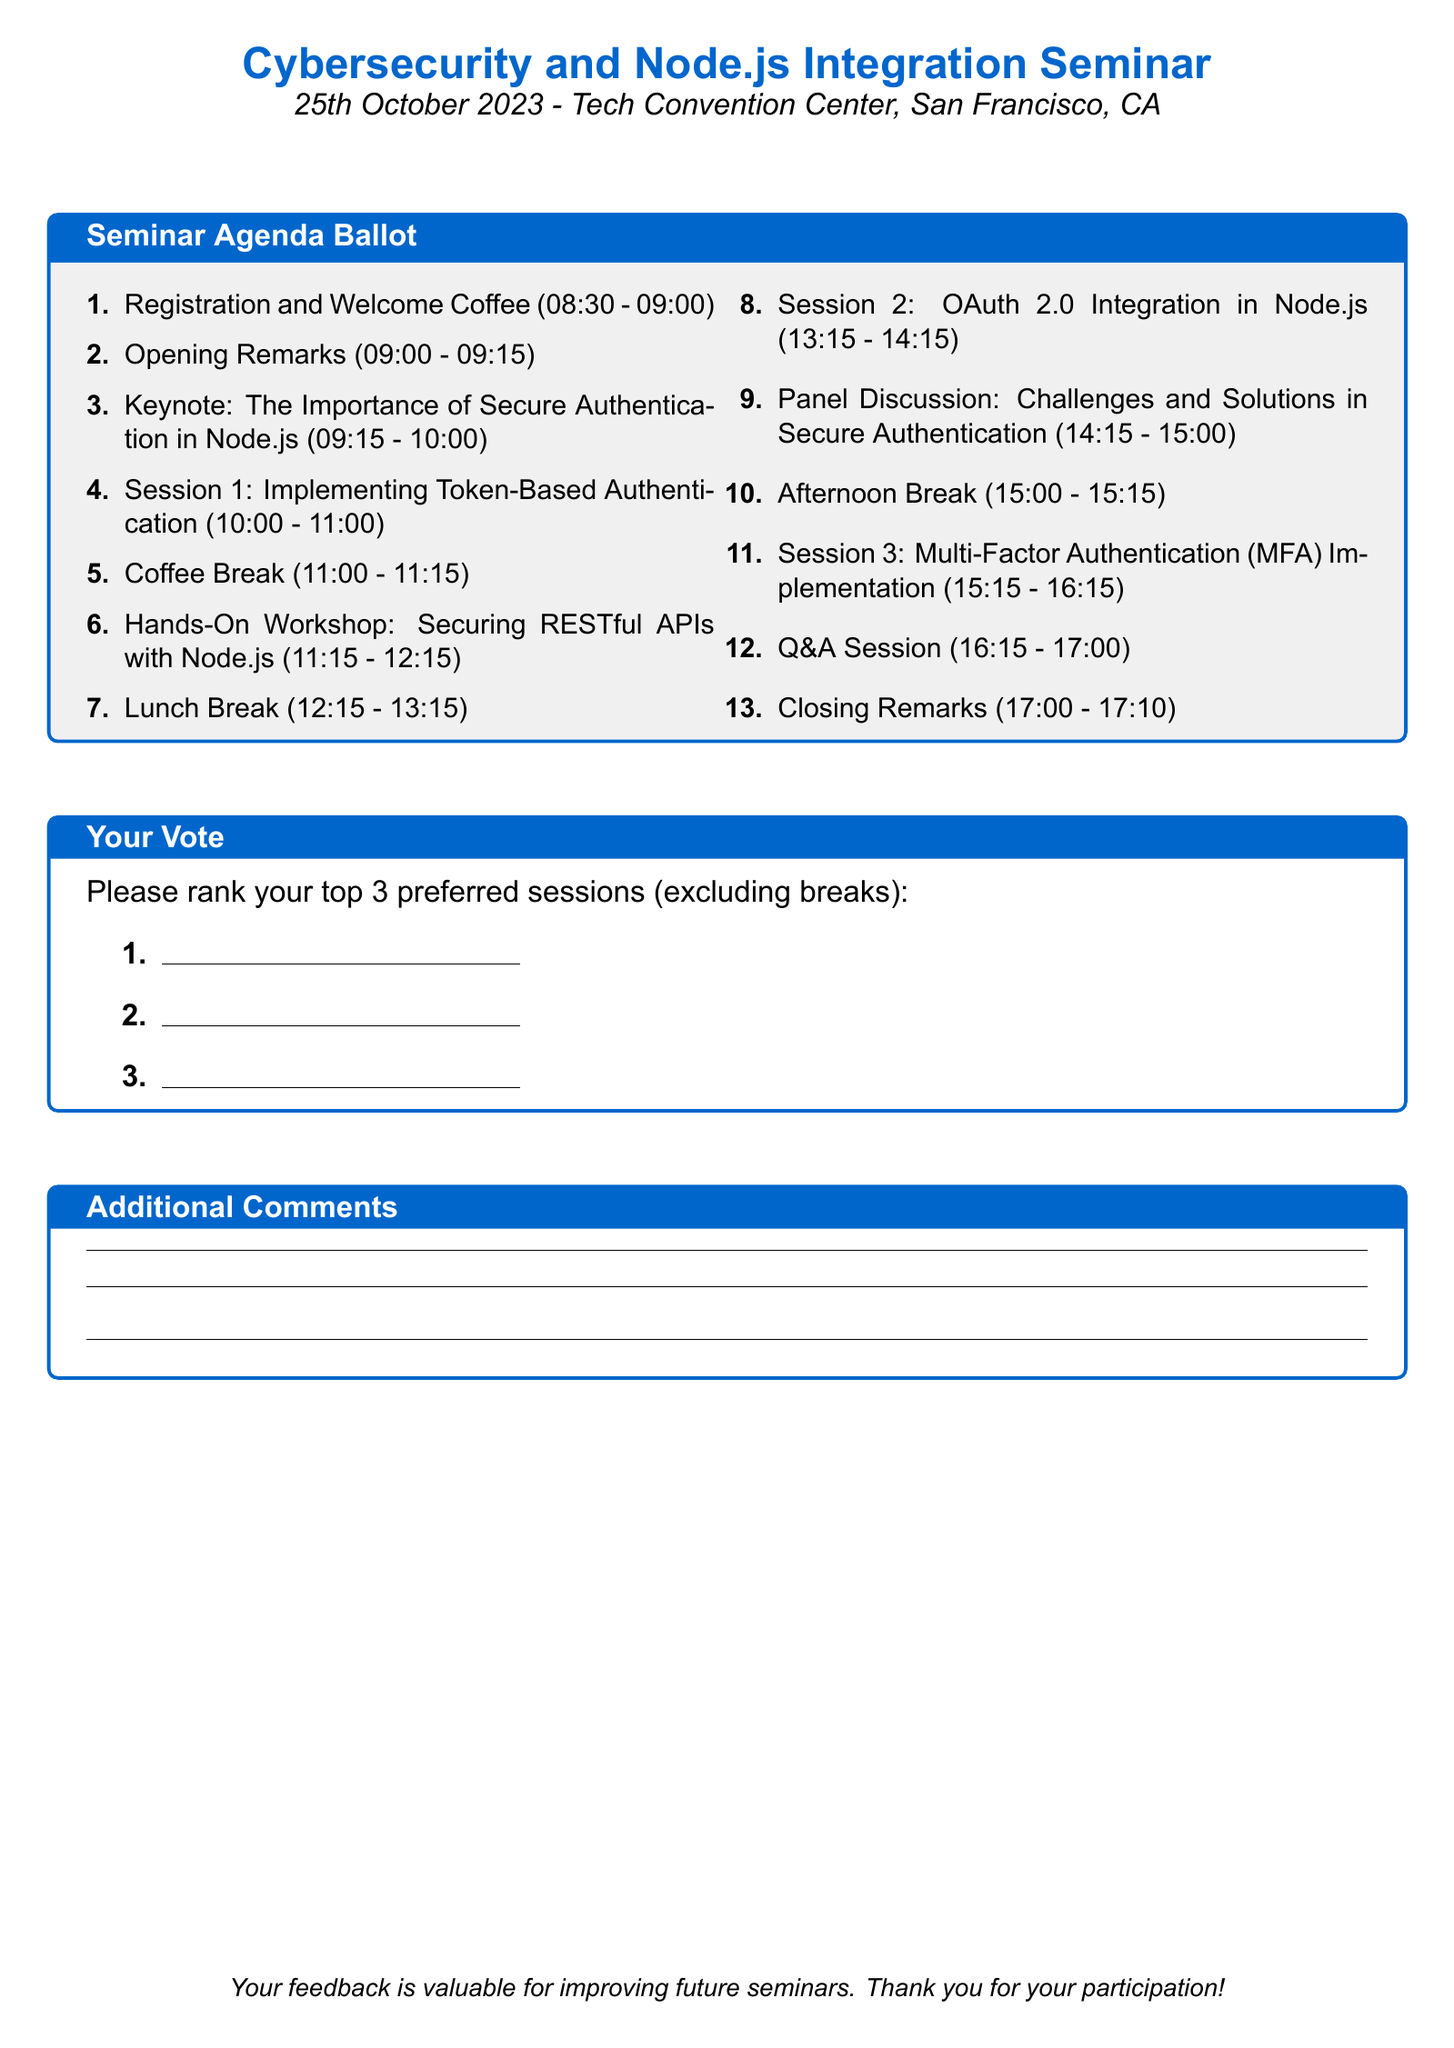What is the date of the seminar? The date is specified at the top of the document as "25th October 2023."
Answer: 25th October 2023 What is the location of the seminar? The location is mentioned in the header as "Tech Convention Center, San Francisco, CA."
Answer: Tech Convention Center, San Francisco, CA What time does the registration start? The document provides a time for registration as "08:30 - 09:00."
Answer: 08:30 How long is the keynote session? The duration of the keynote session is indicated in the document from "09:15 - 10:00," which is 45 minutes.
Answer: 45 minutes What is the title of the keynote speaker? The title given in the document is "The Importance of Secure Authentication in Node.js."
Answer: The Importance of Secure Authentication in Node.js How many sessions are listed before the Q&A? The document lists a total of 5 sessions before the Q&A.
Answer: 5 What is the purpose of the "Your Vote" section? The purpose is for attendees to rank their top 3 preferred sessions, as stated in the document.
Answer: Rank top 3 preferred sessions What is scheduled after the coffee break? The document indicates that a "Hands-On Workshop: Securing RESTful APIs with Node.js" follows the coffee break.
Answer: Hands-On Workshop: Securing RESTful APIs with Node.js What is the total duration of the seminar? The total duration can be calculated from the starting time (08:30) to the ending time (17:10), which totals to 8 hours and 40 minutes.
Answer: 8 hours 40 minutes 